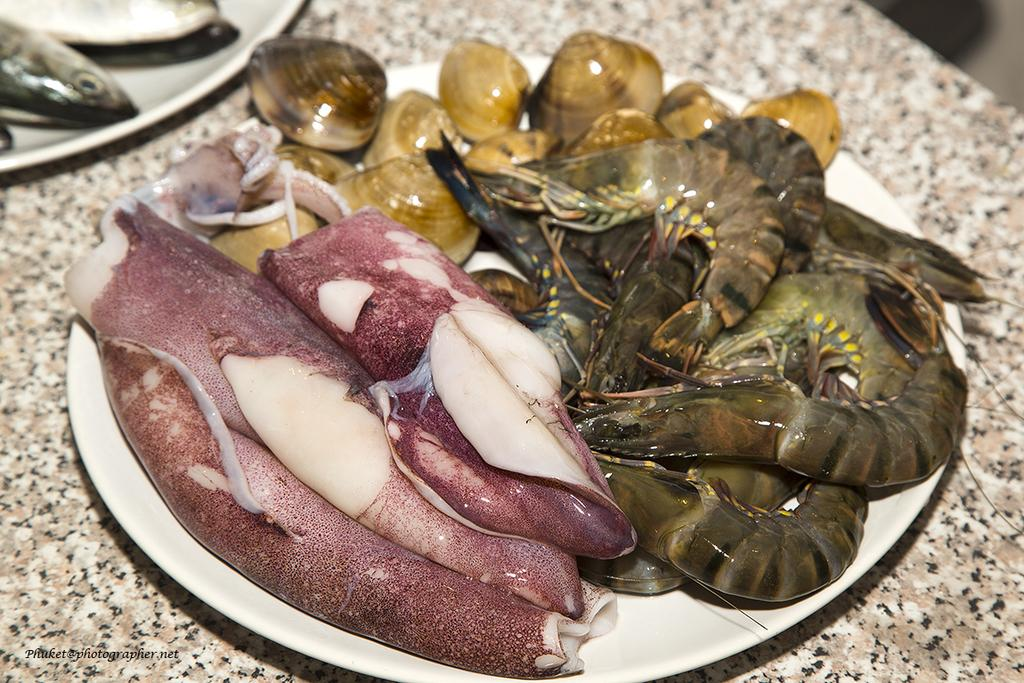What type of animals can be seen in the image? There are aquatic animals in the image. How are the aquatic animals presented in the image? The aquatic animals are in plates. What can be observed about the surface on which the plates are placed? The plates are on a brown and cream color surface. What type of dress is the cook wearing while preparing the aquatic animals in the image? There is no cook or dress present in the image; it features aquatic animals in plates on a brown and cream color surface. 